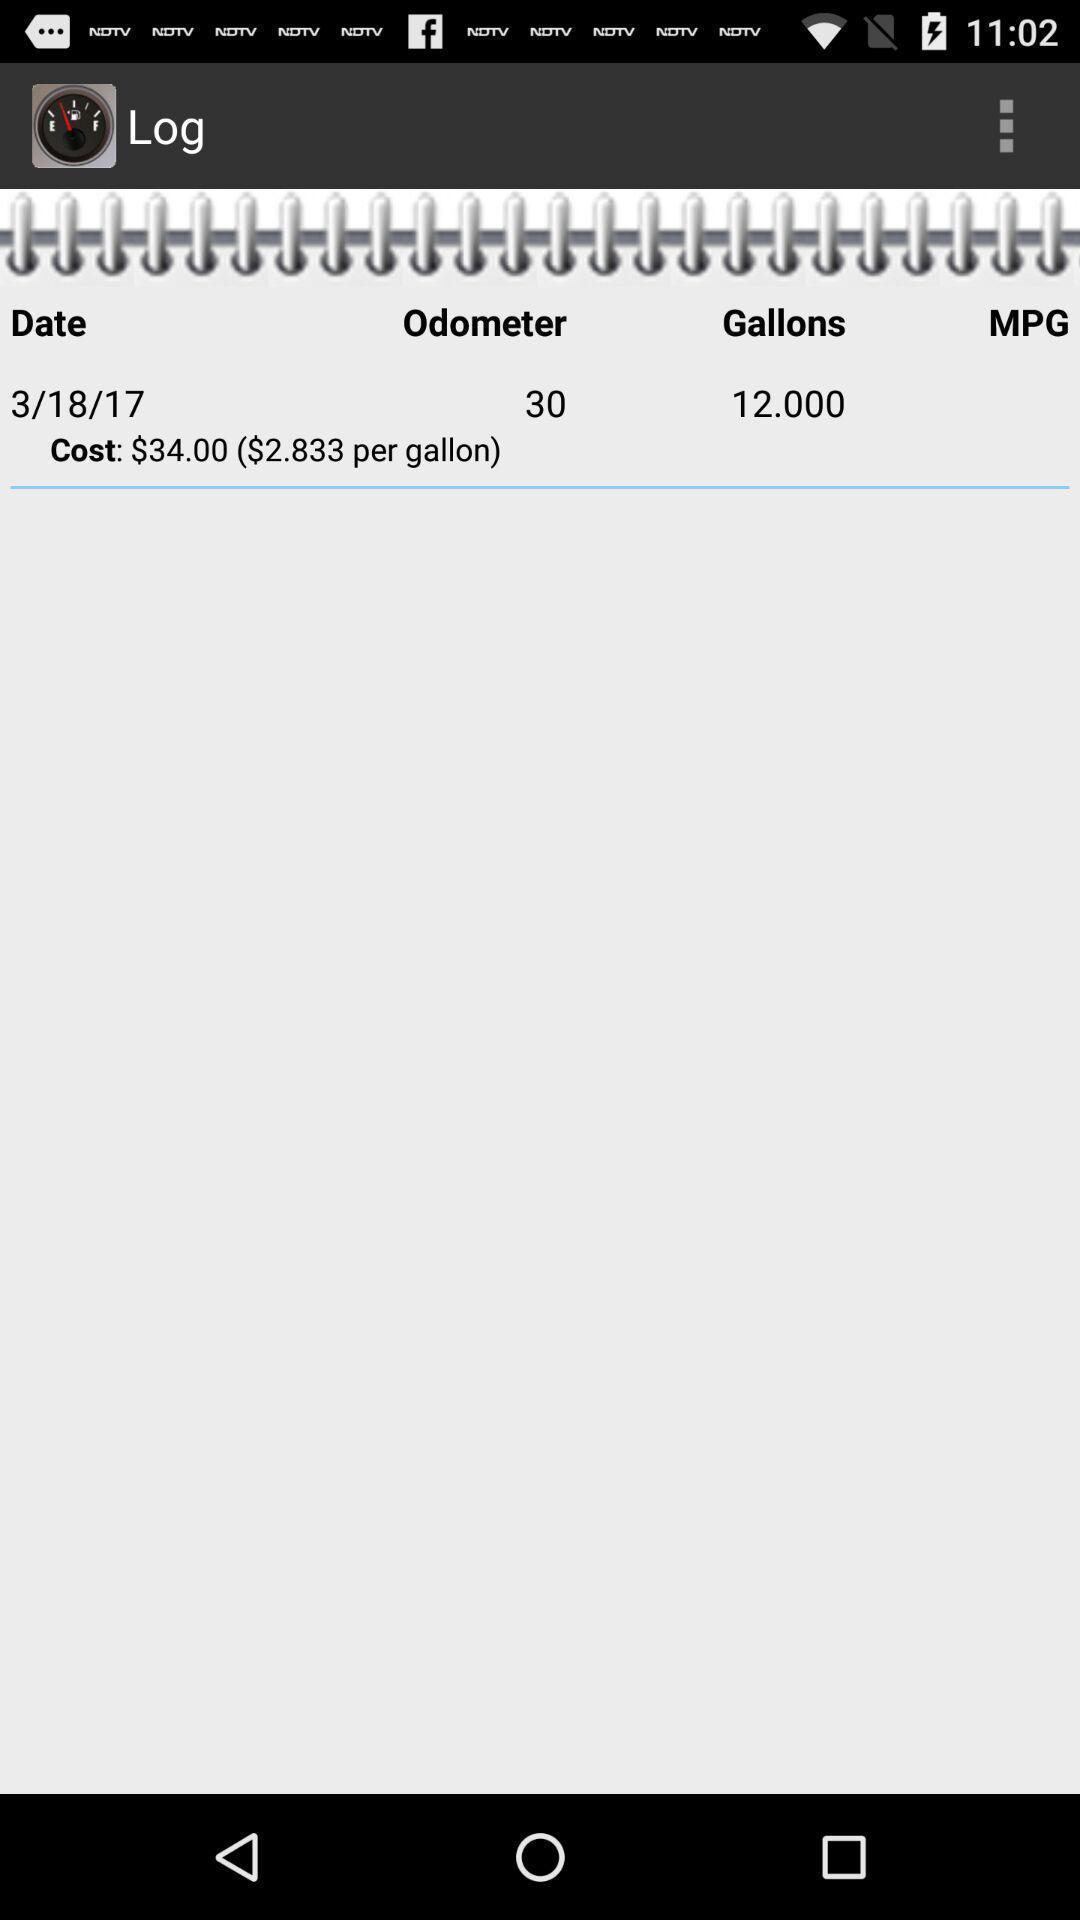Tell me what you see in this picture. Screen displays to track a gas mileage. 